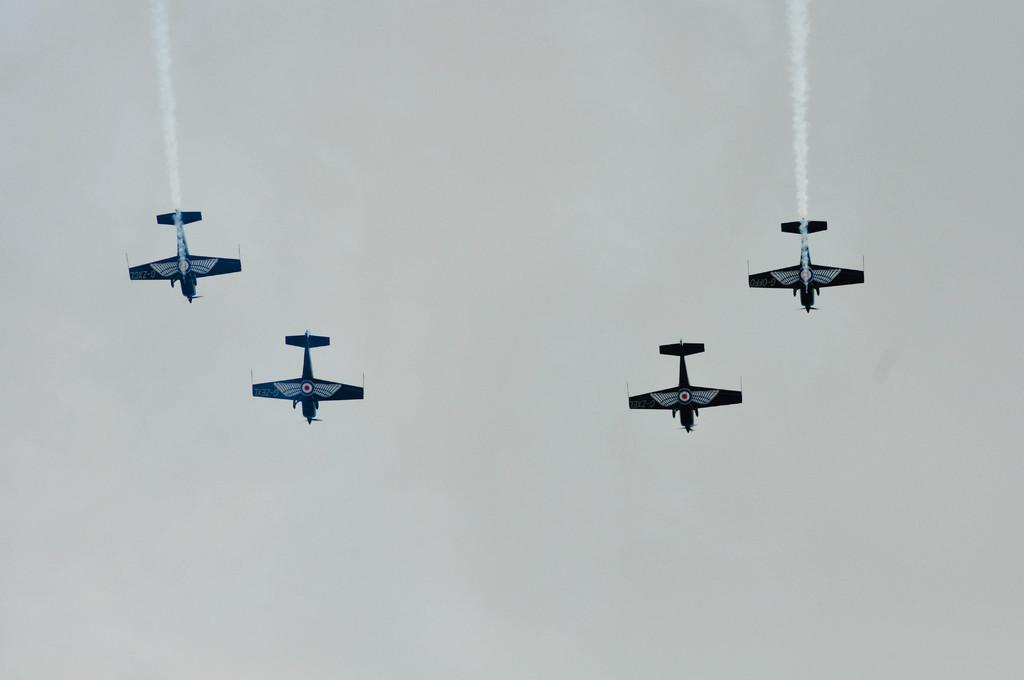How many planes can be seen in the image? There are four planes in the image. What are the planes doing in the image? The planes are flying in the air. What else can be seen in the image besides the planes? There is smoke visible in the image. What route are the planes taking in the image? The provided facts do not mention any specific route or direction the planes are taking. --- Facts: 1. There is a person sitting on a bench in the image. 2. The person is reading a book. 3. There is a tree behind the bench. 4. The sky is visible in the image. Absurd Topics: parrot, ocean, bicycle Conversation: What is the person in the image doing? The person is sitting on a bench in the image. What activity is the person engaged in while sitting on the bench? The person is reading a book. What can be seen behind the bench in the image? There is a tree behind the bench. What is visible in the background of the image? The sky is visible in the image. Reasoning: Let's think step by step in order to produce the conversation. We start by identifying the main subject in the image, which is the person sitting on the bench. Then, we describe what the person is doing, which is reading a book. Next, we mention any other notable details in the image, such as the tree behind the bench and the sky visible in the background. Absurd Question/Answer: Can you see a parrot sitting on the person's shoulder in the image? No, there is no parrot present in the image. 